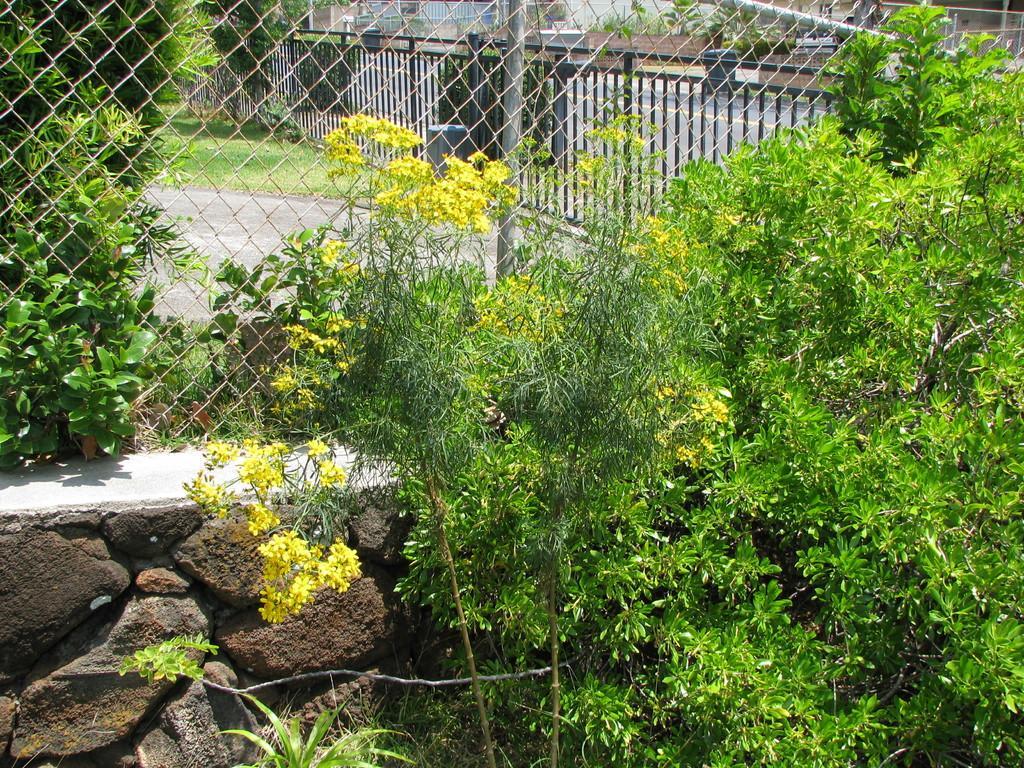Please provide a concise description of this image. In this image there are some plants, flowers and some rocks, and in the center there is a fence. And in the background there is a railing, grass, walkway, poles and some buildings. 